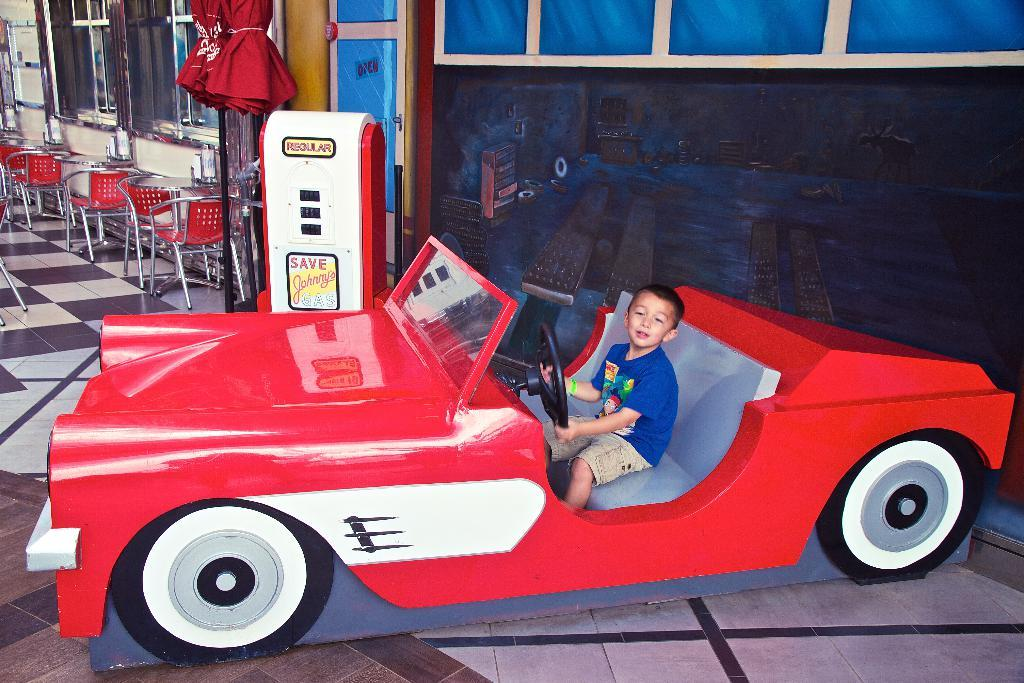What is the main subject of the image? The main subject of the image is a car. Who or what is inside the car? A kid is sitting in the car. What other objects can be seen in the image? There are chairs and windows visible in the image. What type of scissors can be seen cutting the hair of the kid in the car? There are no scissors or hair cutting activity present in the image. 